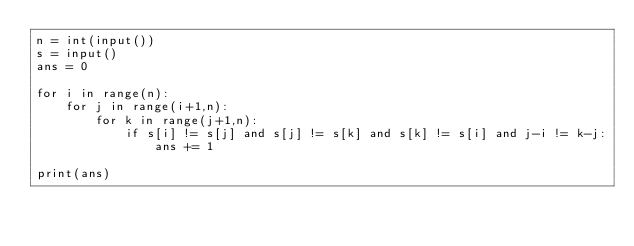<code> <loc_0><loc_0><loc_500><loc_500><_Python_>n = int(input())
s = input()
ans = 0

for i in range(n):
    for j in range(i+1,n):
        for k in range(j+1,n):
            if s[i] != s[j] and s[j] != s[k] and s[k] != s[i] and j-i != k-j:
          	    ans += 1
            	
print(ans)
</code> 